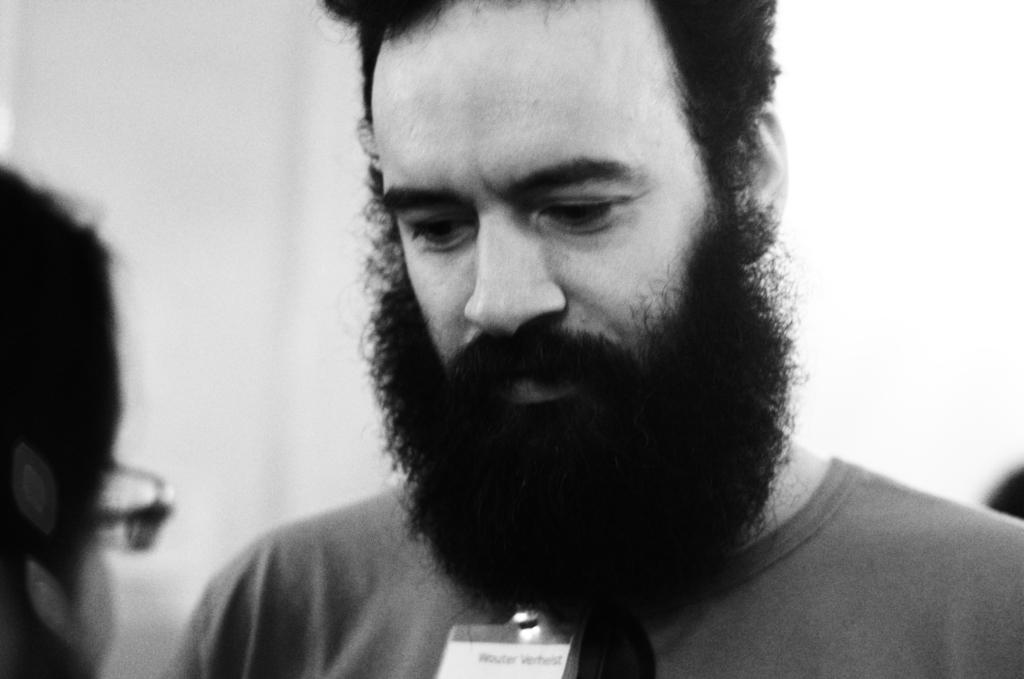What is the color scheme of the image? The image is black and white. Who is the main subject in the image? There is a bearded man in the image. Where is the bearded man located in the image? The bearded man is standing in the middle of the image. Are there any other people in the image? Yes, there is another person in the image. What type of secretary can be seen working in the market in the image? There is no secretary or market present in the image; it features a bearded man standing in the middle of the image. 